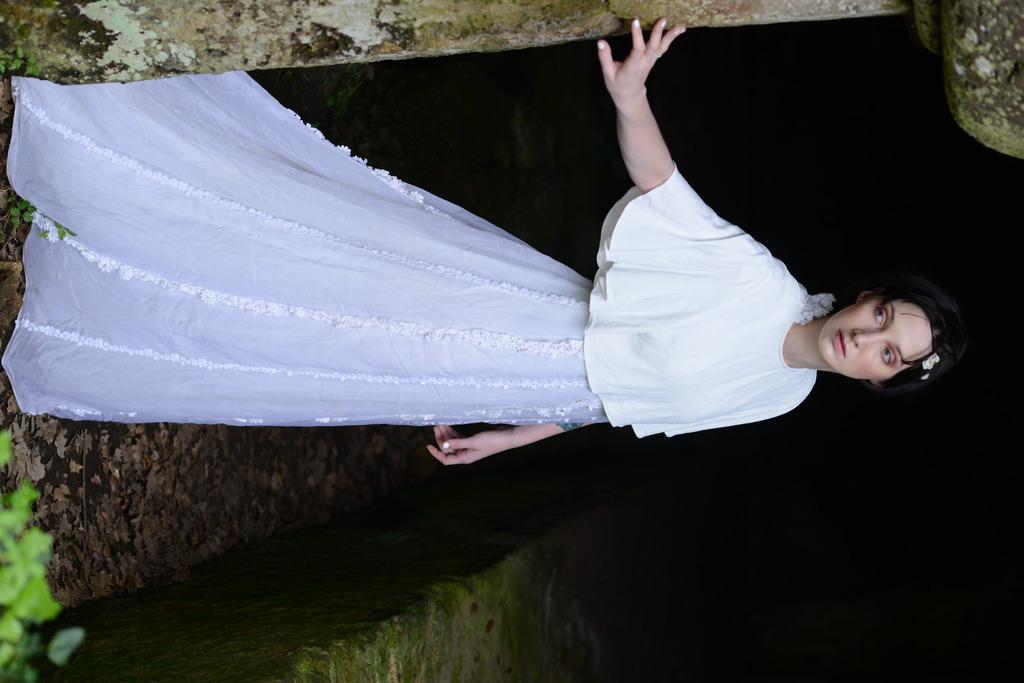Describe this image in one or two sentences. In this picture, we see a woman in the white dress is standing and she is posing for the photo. At the top, we see a wall and a rock. At the bottom, we see a wall and the dry leaves. In the left bottom, we see a plant. In the background, it is black in color. 